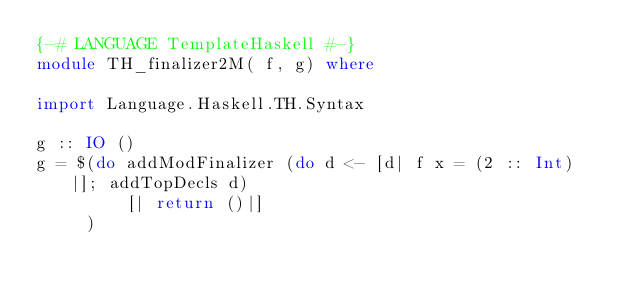Convert code to text. <code><loc_0><loc_0><loc_500><loc_500><_Haskell_>{-# LANGUAGE TemplateHaskell #-}
module TH_finalizer2M( f, g) where

import Language.Haskell.TH.Syntax

g :: IO ()
g = $(do addModFinalizer (do d <- [d| f x = (2 :: Int) |]; addTopDecls d)
         [| return ()|]
     )
</code> 